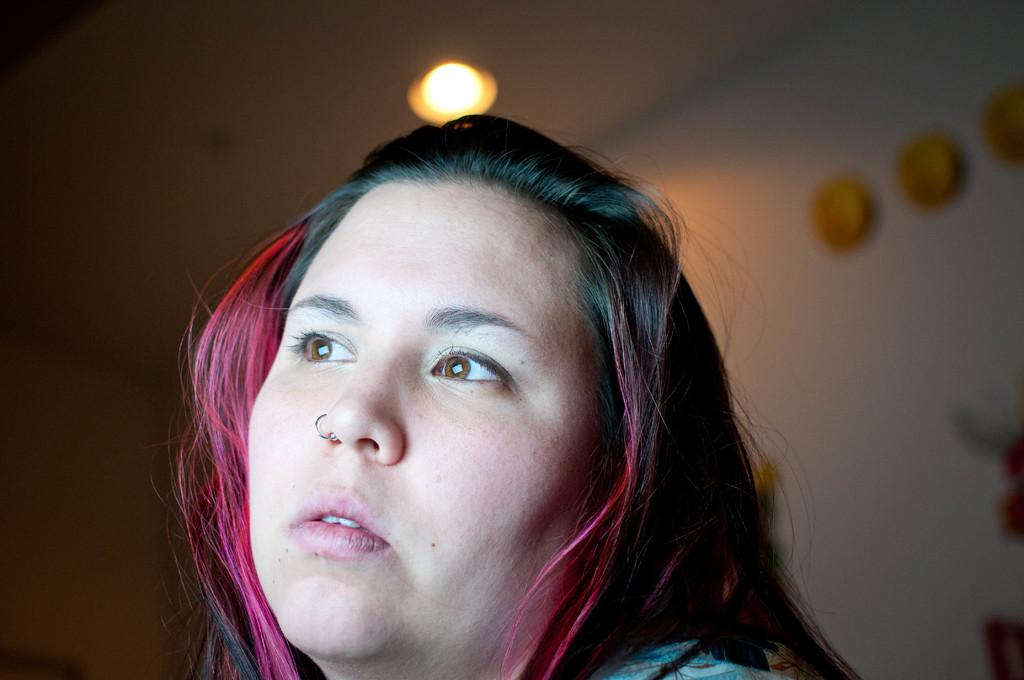Who is the main subject in the foreground of the image? There is a woman in the foreground of the image. What can be observed about the background of the image? The background of the image is blurry. What can be seen in the image besides the woman? There are lights and objects visible in the image. What type of structure is present in the image? There is a wall in the image. What year is depicted in the image? The provided facts do not mention any specific year, so it cannot be determined from the image. Can you see a pan in the image? There is no pan present in the image. 